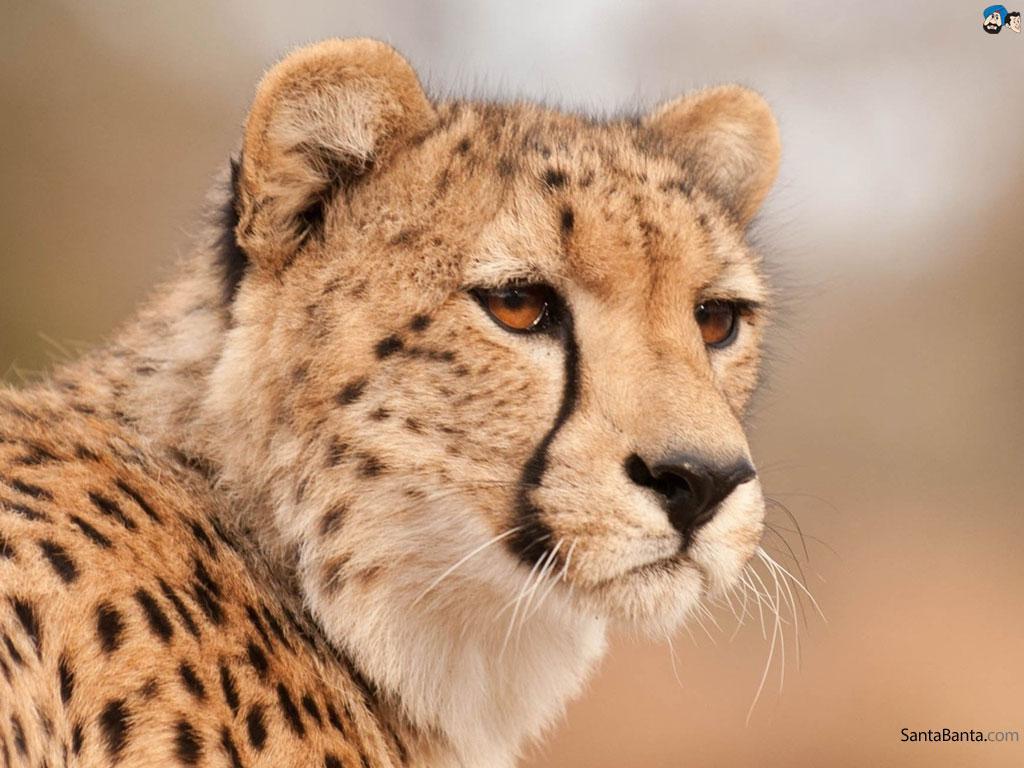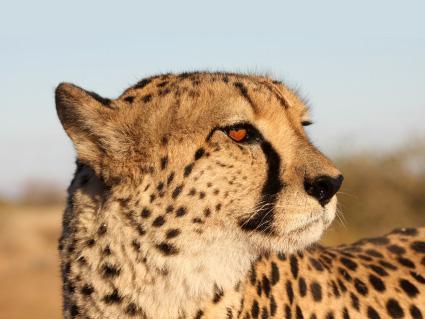The first image is the image on the left, the second image is the image on the right. Assess this claim about the two images: "There is at least 1 leopard kitten.". Correct or not? Answer yes or no. No. 